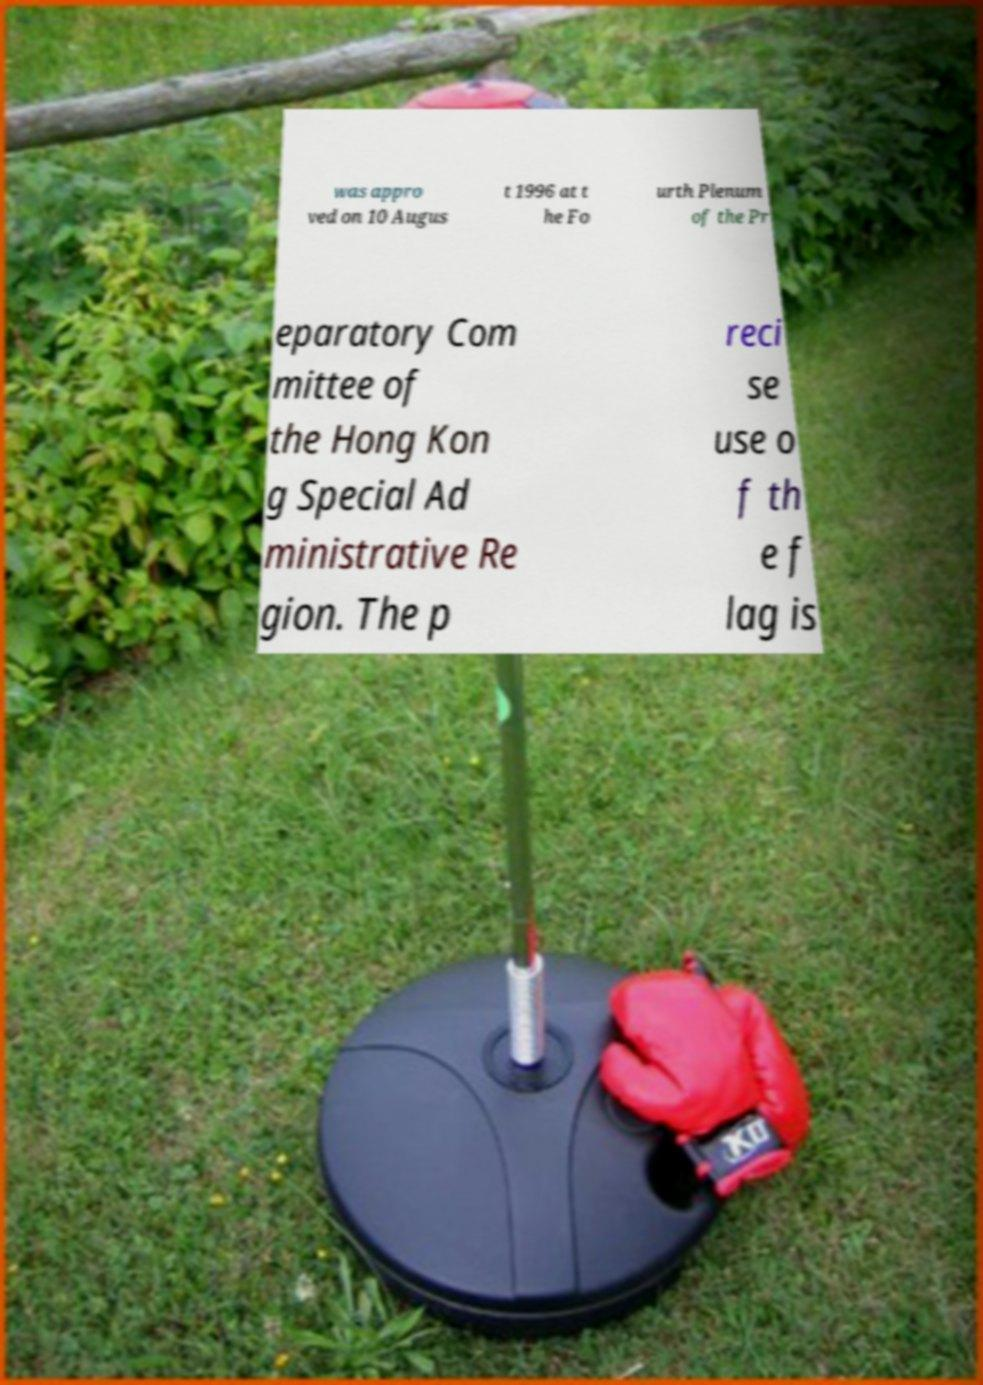Could you assist in decoding the text presented in this image and type it out clearly? was appro ved on 10 Augus t 1996 at t he Fo urth Plenum of the Pr eparatory Com mittee of the Hong Kon g Special Ad ministrative Re gion. The p reci se use o f th e f lag is 